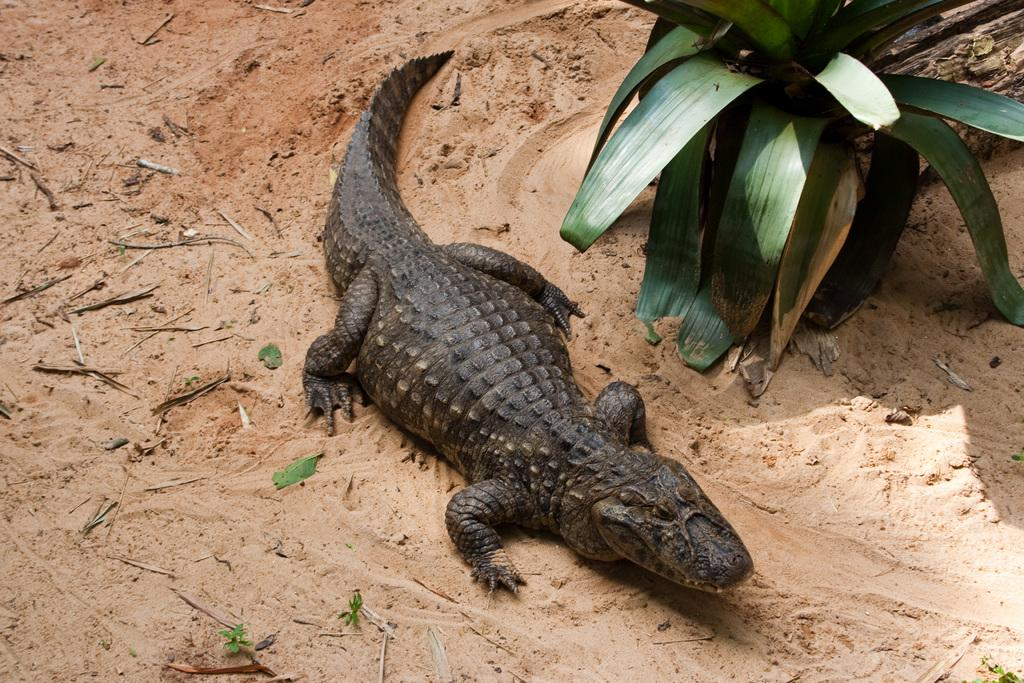What type of animal is on the ground in the image? There is a crocodile on the ground in the image. What other object or living organism can be seen in the image? There is a plant in the image. What type of cloud can be seen in the image? There is no cloud present in the image; it only features a crocodile and a plant. What kind of experience does the crocodile have with the plant in the image? The image does not provide any information about the crocodile's experience with the plant, as it only shows the crocodile and the plant. 